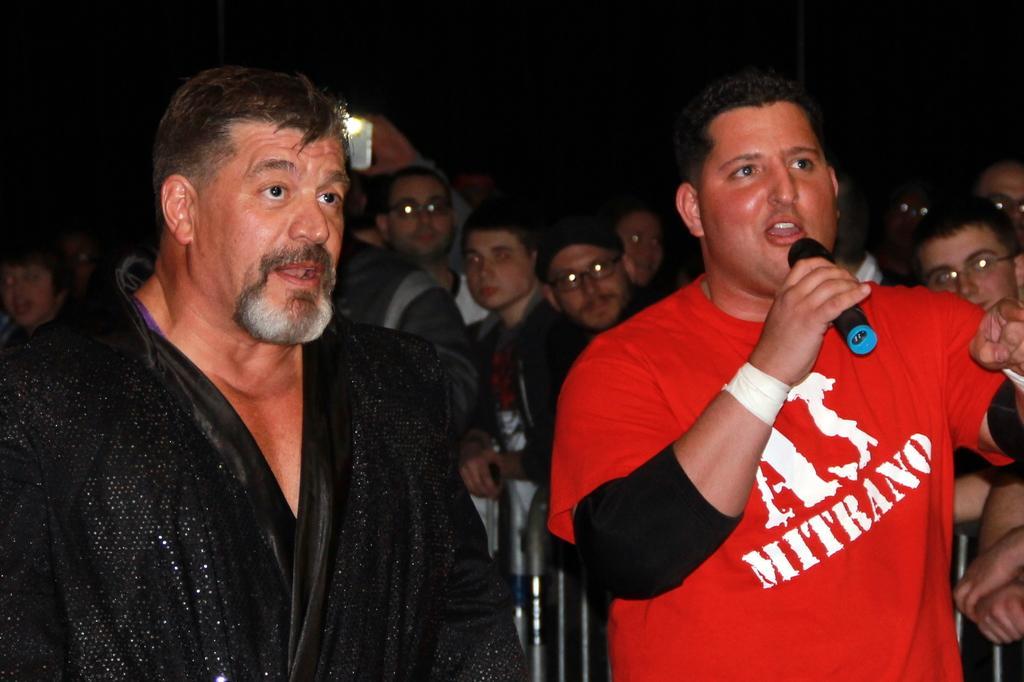Can you describe this image briefly? In this picture we can see a group of people standing and a man in the red t shirt is holding a microphone and another person holding an object. In front of the people there are barriers. Behind the people there is a dark background. 